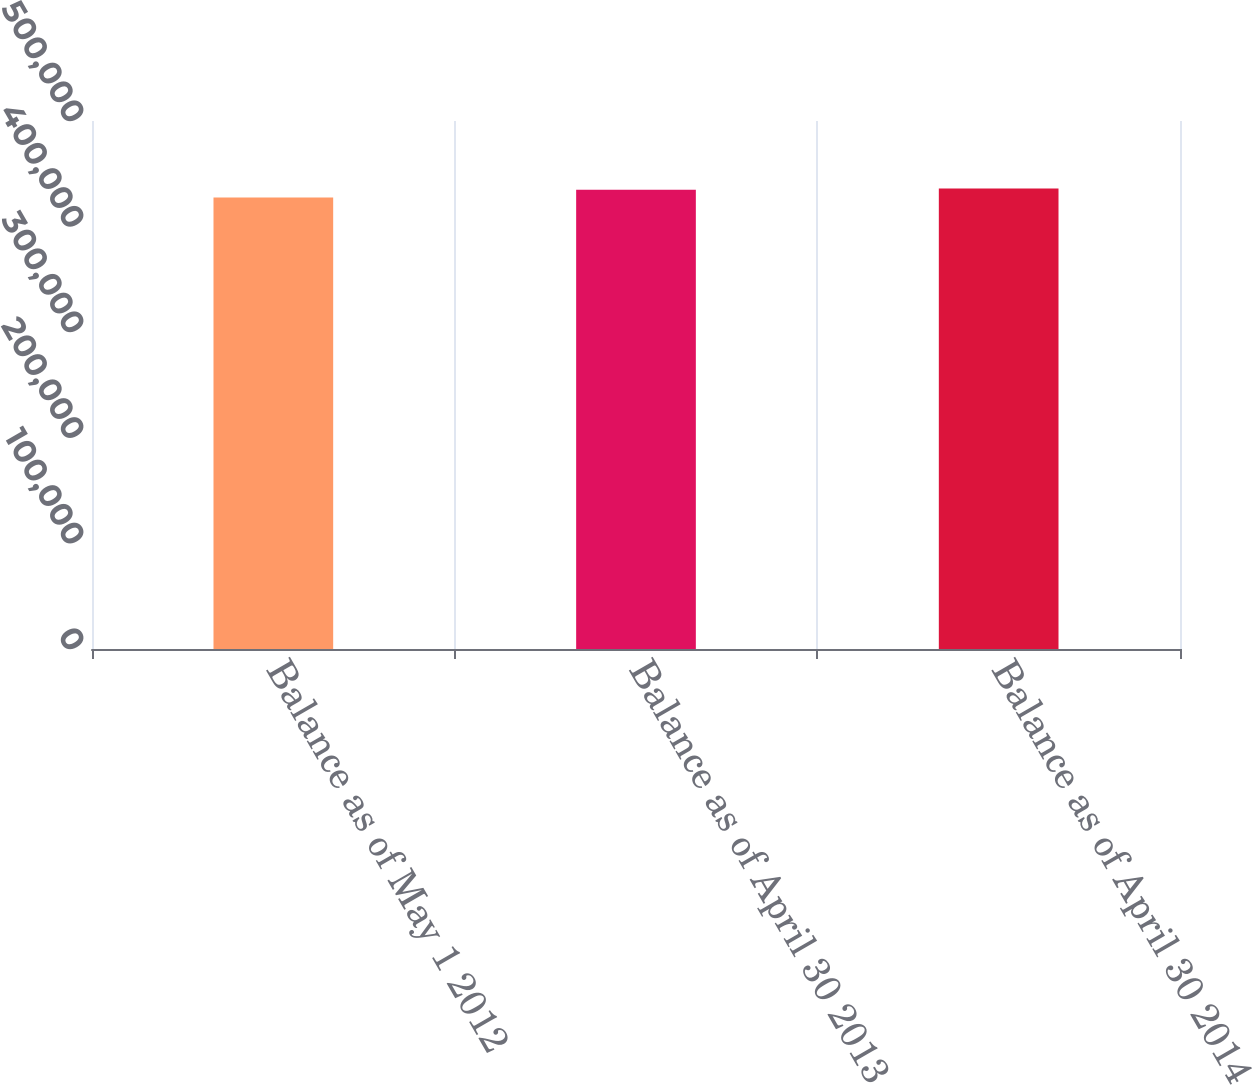<chart> <loc_0><loc_0><loc_500><loc_500><bar_chart><fcel>Balance as of May 1 2012<fcel>Balance as of April 30 2013<fcel>Balance as of April 30 2014<nl><fcel>427566<fcel>434782<fcel>436117<nl></chart> 